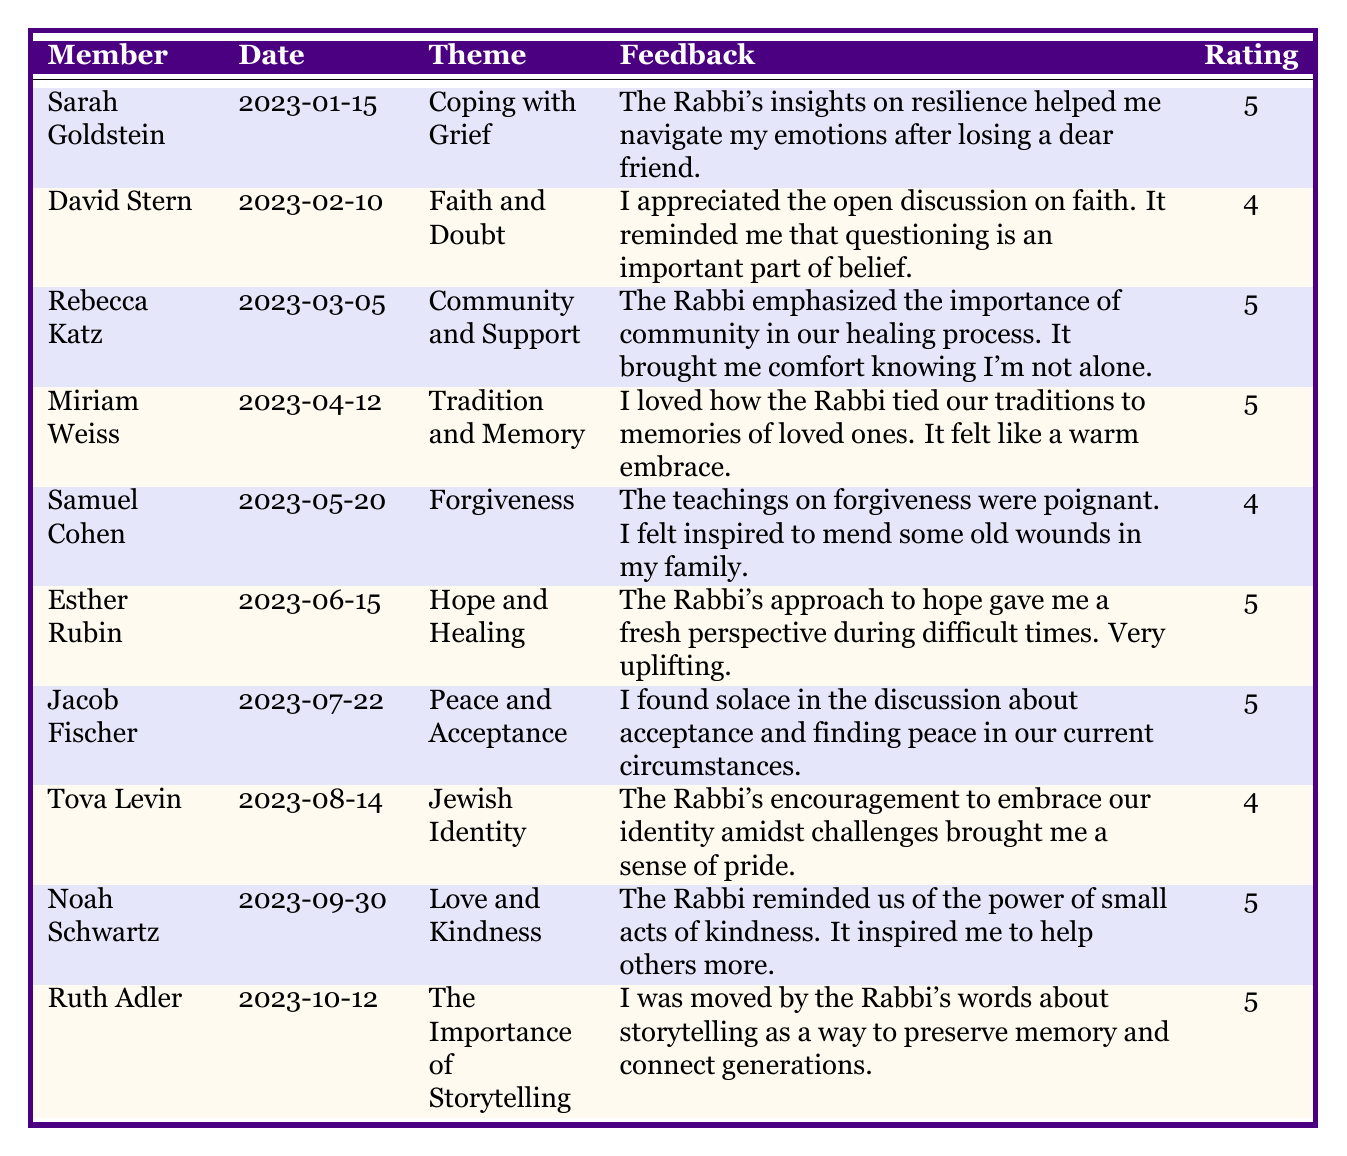What was the feedback from Sarah Goldstein? Sarah Goldstein provided feedback on the theme "Coping with Grief" on 2023-01-15, stating that the Rabbi's insights on resilience helped her navigate her emotions after losing a dear friend.
Answer: The Rabbi's insights on resilience helped me navigate my emotions after losing a dear friend How many members rated the teaching on "Forgiveness" with a 4? Samuel Cohen is the only member who provided feedback on the theme "Forgiveness" and rated it with a 4.
Answer: 1 What was the highest rating given, and who gave it? The highest rating is 5, and it was given by Sarah Goldstein, Rebecca Katz, Miriam Weiss, Esther Rubin, Jacob Fischer, Noah Schwartz, and Ruth Adler.
Answer: 5, by multiple members How many sessions focused on themes related to healing? The sessions with themes "Coping with Grief," "Hope and Healing," "Peace and Acceptance," and "Community and Support" are related to healing, totaling four sessions.
Answer: 4 What is the average rating for all the sessions listed? The ratings given are 5, 4, 5, 5, 4, 5, 5, 4, 5, and 5, which total up to 50. There are 10 sessions, so the average rating is 50 / 10 = 5.
Answer: 5 Which theme received the most consistent feedback (5 rating)? The themes "Coping with Grief," "Community and Support," "Tradition and Memory," "Hope and Healing," "Peace and Acceptance," "Love and Kindness," and "The Importance of Storytelling" all received ratings of 5, ensuring consistent feedback.
Answer: Multiple themes received consistent feedback Did any member express that the Rabbi's teachings inspired them to help others more? Yes, Noah Schwartz expressed that the Rabbi reminded the congregation of the power of small acts of kindness, which inspired him to help others more.
Answer: Yes How many members commented on the theme "Jewish Identity," and what was their rating? Tova Levin commented on the theme "Jewish Identity," giving it a rating of 4.
Answer: 1 member, rating 4 